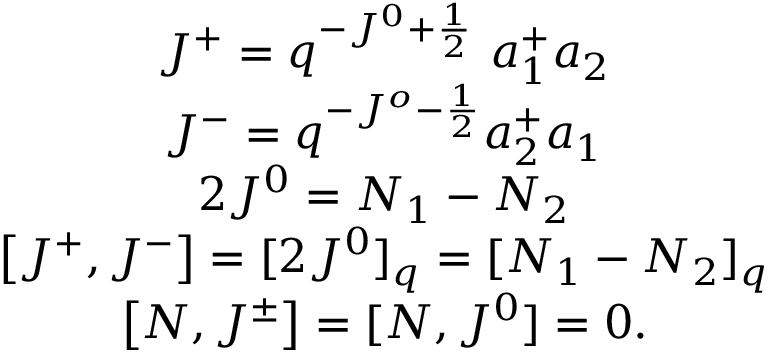<formula> <loc_0><loc_0><loc_500><loc_500>\begin{array} { c } { { J ^ { + } = q ^ { - J ^ { 0 } + \frac { 1 } { 2 } } \ a _ { 1 } ^ { + } a _ { 2 } } } \\ { { J ^ { - } = q ^ { - J ^ { o } - \frac { 1 } { 2 } } a _ { 2 } ^ { + } a _ { 1 } } } \\ { { 2 J ^ { 0 } = N _ { 1 } - N _ { 2 } } } \\ { { \left [ J ^ { + } , J ^ { - } \right ] = [ 2 J ^ { 0 } ] _ { q } = [ N _ { 1 } - N _ { 2 } ] _ { q } } } \\ { { \left [ N , J ^ { \pm } \right ] = [ N , J ^ { 0 } ] = 0 . } } \end{array}</formula> 